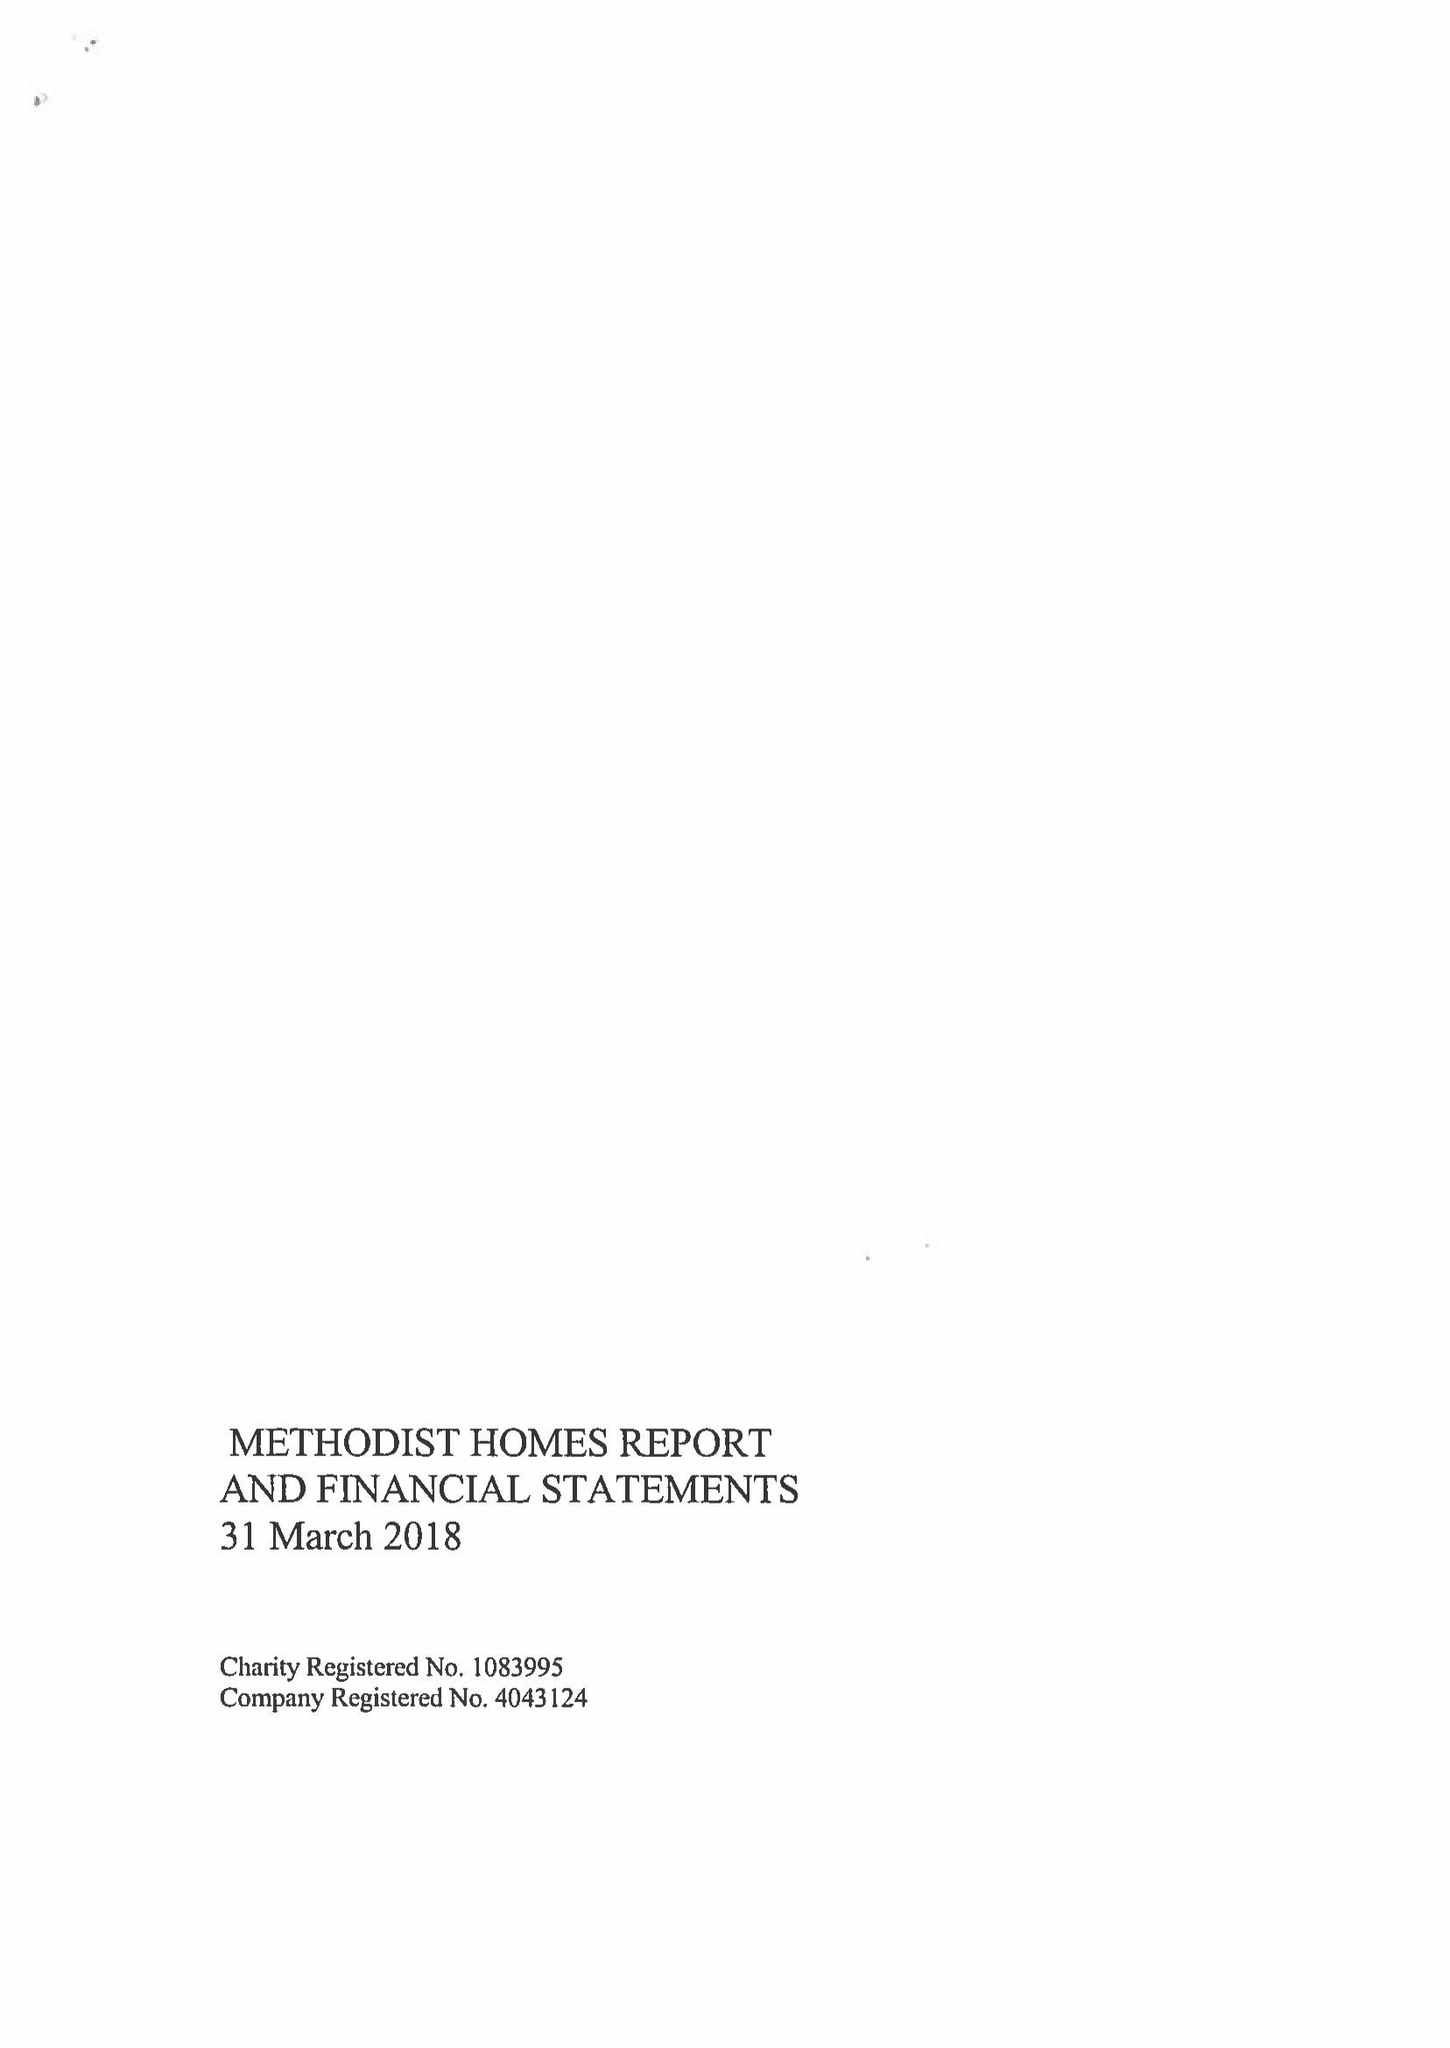What is the value for the income_annually_in_british_pounds?
Answer the question using a single word or phrase. 229430000.00 